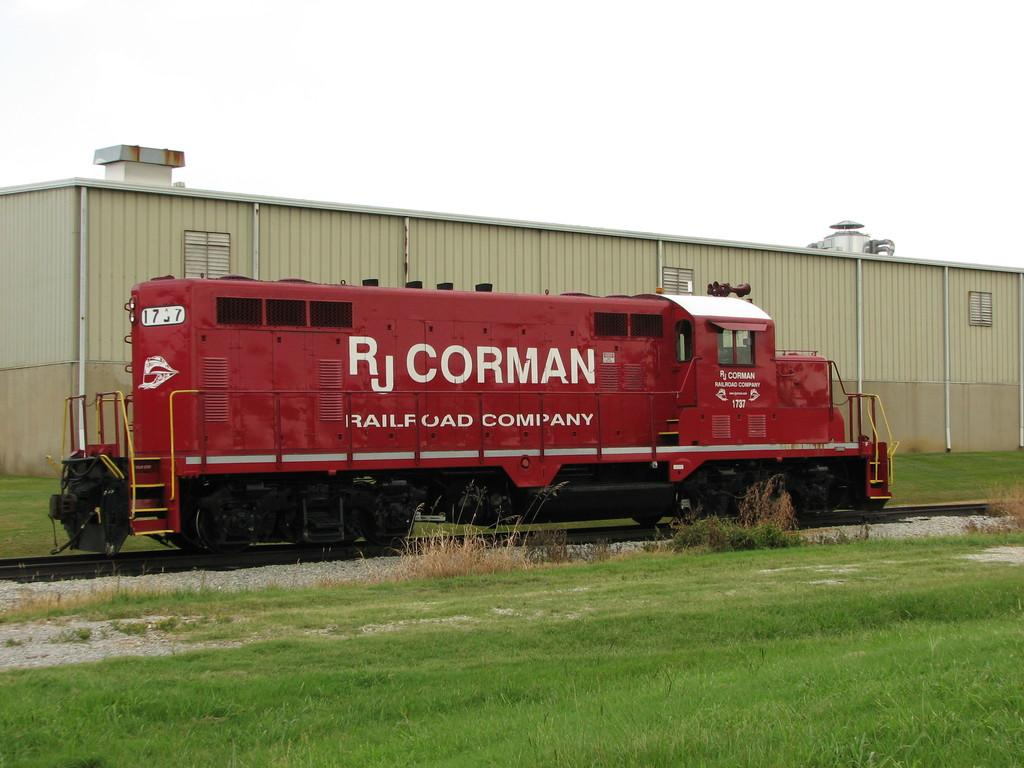<image>
Write a terse but informative summary of the picture. A red Rj Corman freight train parked on a track in front of a large building. 